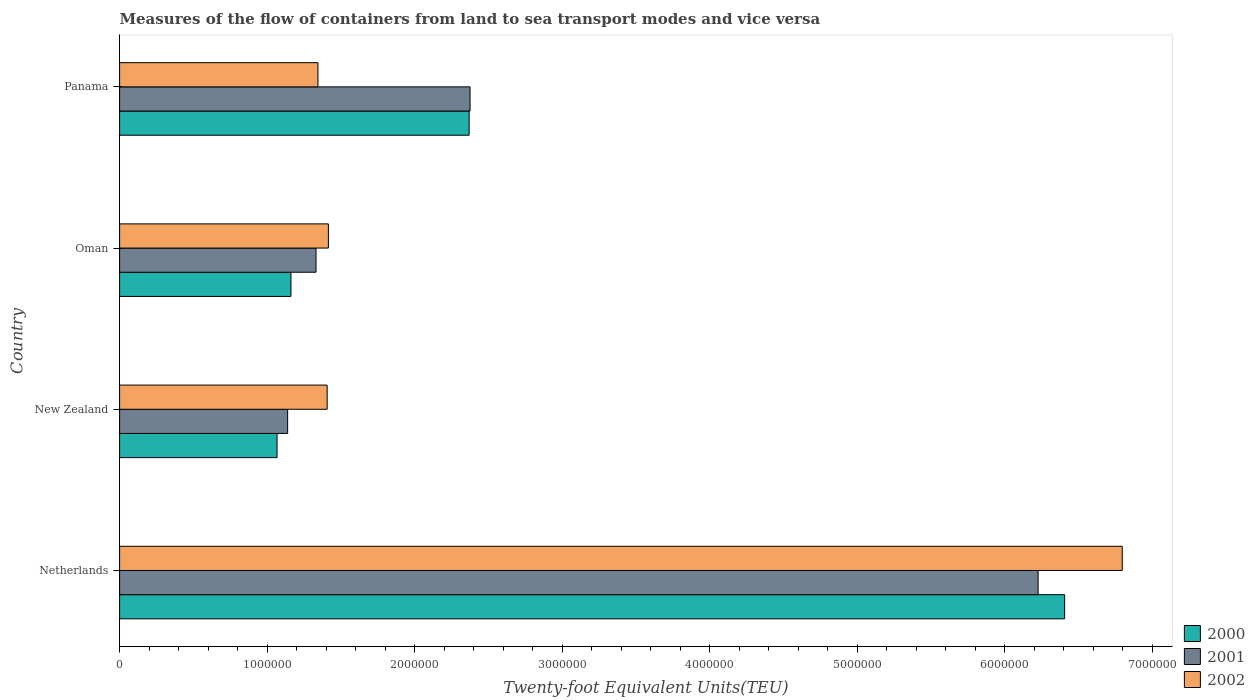Are the number of bars per tick equal to the number of legend labels?
Your answer should be very brief. Yes. How many bars are there on the 2nd tick from the bottom?
Your answer should be very brief. 3. What is the label of the 1st group of bars from the top?
Your answer should be very brief. Panama. In how many cases, is the number of bars for a given country not equal to the number of legend labels?
Your response must be concise. 0. What is the container port traffic in 2001 in Netherlands?
Your response must be concise. 6.23e+06. Across all countries, what is the maximum container port traffic in 2001?
Offer a very short reply. 6.23e+06. Across all countries, what is the minimum container port traffic in 2000?
Keep it short and to the point. 1.07e+06. In which country was the container port traffic in 2001 maximum?
Your answer should be very brief. Netherlands. In which country was the container port traffic in 2001 minimum?
Give a very brief answer. New Zealand. What is the total container port traffic in 2002 in the graph?
Your answer should be very brief. 1.10e+07. What is the difference between the container port traffic in 2000 in New Zealand and that in Oman?
Provide a short and direct response. -9.41e+04. What is the difference between the container port traffic in 2001 in Panama and the container port traffic in 2002 in Oman?
Provide a succinct answer. 9.61e+05. What is the average container port traffic in 2002 per country?
Your answer should be compact. 2.74e+06. What is the difference between the container port traffic in 2002 and container port traffic in 2001 in Oman?
Give a very brief answer. 8.38e+04. In how many countries, is the container port traffic in 2002 greater than 600000 TEU?
Give a very brief answer. 4. What is the ratio of the container port traffic in 2002 in Netherlands to that in Oman?
Keep it short and to the point. 4.8. What is the difference between the highest and the second highest container port traffic in 2002?
Offer a very short reply. 5.38e+06. What is the difference between the highest and the lowest container port traffic in 2002?
Ensure brevity in your answer.  5.45e+06. What does the 3rd bar from the top in Netherlands represents?
Provide a succinct answer. 2000. What is the difference between two consecutive major ticks on the X-axis?
Offer a terse response. 1.00e+06. Are the values on the major ticks of X-axis written in scientific E-notation?
Offer a very short reply. No. Does the graph contain any zero values?
Offer a very short reply. No. Does the graph contain grids?
Provide a succinct answer. No. What is the title of the graph?
Give a very brief answer. Measures of the flow of containers from land to sea transport modes and vice versa. What is the label or title of the X-axis?
Give a very brief answer. Twenty-foot Equivalent Units(TEU). What is the label or title of the Y-axis?
Provide a short and direct response. Country. What is the Twenty-foot Equivalent Units(TEU) in 2000 in Netherlands?
Keep it short and to the point. 6.41e+06. What is the Twenty-foot Equivalent Units(TEU) in 2001 in Netherlands?
Offer a very short reply. 6.23e+06. What is the Twenty-foot Equivalent Units(TEU) of 2002 in Netherlands?
Make the answer very short. 6.80e+06. What is the Twenty-foot Equivalent Units(TEU) of 2000 in New Zealand?
Ensure brevity in your answer.  1.07e+06. What is the Twenty-foot Equivalent Units(TEU) in 2001 in New Zealand?
Your answer should be very brief. 1.14e+06. What is the Twenty-foot Equivalent Units(TEU) of 2002 in New Zealand?
Ensure brevity in your answer.  1.41e+06. What is the Twenty-foot Equivalent Units(TEU) of 2000 in Oman?
Your response must be concise. 1.16e+06. What is the Twenty-foot Equivalent Units(TEU) of 2001 in Oman?
Give a very brief answer. 1.33e+06. What is the Twenty-foot Equivalent Units(TEU) in 2002 in Oman?
Your answer should be compact. 1.42e+06. What is the Twenty-foot Equivalent Units(TEU) of 2000 in Panama?
Provide a short and direct response. 2.37e+06. What is the Twenty-foot Equivalent Units(TEU) of 2001 in Panama?
Keep it short and to the point. 2.38e+06. What is the Twenty-foot Equivalent Units(TEU) in 2002 in Panama?
Offer a terse response. 1.34e+06. Across all countries, what is the maximum Twenty-foot Equivalent Units(TEU) in 2000?
Your answer should be compact. 6.41e+06. Across all countries, what is the maximum Twenty-foot Equivalent Units(TEU) in 2001?
Provide a short and direct response. 6.23e+06. Across all countries, what is the maximum Twenty-foot Equivalent Units(TEU) in 2002?
Your response must be concise. 6.80e+06. Across all countries, what is the minimum Twenty-foot Equivalent Units(TEU) in 2000?
Provide a succinct answer. 1.07e+06. Across all countries, what is the minimum Twenty-foot Equivalent Units(TEU) of 2001?
Offer a terse response. 1.14e+06. Across all countries, what is the minimum Twenty-foot Equivalent Units(TEU) of 2002?
Offer a very short reply. 1.34e+06. What is the total Twenty-foot Equivalent Units(TEU) of 2000 in the graph?
Provide a short and direct response. 1.10e+07. What is the total Twenty-foot Equivalent Units(TEU) in 2001 in the graph?
Provide a short and direct response. 1.11e+07. What is the total Twenty-foot Equivalent Units(TEU) in 2002 in the graph?
Give a very brief answer. 1.10e+07. What is the difference between the Twenty-foot Equivalent Units(TEU) in 2000 in Netherlands and that in New Zealand?
Your answer should be very brief. 5.34e+06. What is the difference between the Twenty-foot Equivalent Units(TEU) in 2001 in Netherlands and that in New Zealand?
Keep it short and to the point. 5.09e+06. What is the difference between the Twenty-foot Equivalent Units(TEU) in 2002 in Netherlands and that in New Zealand?
Provide a succinct answer. 5.39e+06. What is the difference between the Twenty-foot Equivalent Units(TEU) in 2000 in Netherlands and that in Oman?
Your response must be concise. 5.25e+06. What is the difference between the Twenty-foot Equivalent Units(TEU) of 2001 in Netherlands and that in Oman?
Provide a short and direct response. 4.90e+06. What is the difference between the Twenty-foot Equivalent Units(TEU) of 2002 in Netherlands and that in Oman?
Offer a terse response. 5.38e+06. What is the difference between the Twenty-foot Equivalent Units(TEU) of 2000 in Netherlands and that in Panama?
Keep it short and to the point. 4.04e+06. What is the difference between the Twenty-foot Equivalent Units(TEU) of 2001 in Netherlands and that in Panama?
Offer a terse response. 3.85e+06. What is the difference between the Twenty-foot Equivalent Units(TEU) in 2002 in Netherlands and that in Panama?
Your answer should be compact. 5.45e+06. What is the difference between the Twenty-foot Equivalent Units(TEU) of 2000 in New Zealand and that in Oman?
Provide a succinct answer. -9.41e+04. What is the difference between the Twenty-foot Equivalent Units(TEU) in 2001 in New Zealand and that in Oman?
Provide a succinct answer. -1.93e+05. What is the difference between the Twenty-foot Equivalent Units(TEU) in 2002 in New Zealand and that in Oman?
Give a very brief answer. -8370. What is the difference between the Twenty-foot Equivalent Units(TEU) of 2000 in New Zealand and that in Panama?
Provide a short and direct response. -1.30e+06. What is the difference between the Twenty-foot Equivalent Units(TEU) in 2001 in New Zealand and that in Panama?
Ensure brevity in your answer.  -1.24e+06. What is the difference between the Twenty-foot Equivalent Units(TEU) in 2002 in New Zealand and that in Panama?
Offer a terse response. 6.23e+04. What is the difference between the Twenty-foot Equivalent Units(TEU) of 2000 in Oman and that in Panama?
Provide a short and direct response. -1.21e+06. What is the difference between the Twenty-foot Equivalent Units(TEU) in 2001 in Oman and that in Panama?
Give a very brief answer. -1.04e+06. What is the difference between the Twenty-foot Equivalent Units(TEU) in 2002 in Oman and that in Panama?
Your response must be concise. 7.07e+04. What is the difference between the Twenty-foot Equivalent Units(TEU) of 2000 in Netherlands and the Twenty-foot Equivalent Units(TEU) of 2001 in New Zealand?
Keep it short and to the point. 5.27e+06. What is the difference between the Twenty-foot Equivalent Units(TEU) in 2000 in Netherlands and the Twenty-foot Equivalent Units(TEU) in 2002 in New Zealand?
Your answer should be compact. 5.00e+06. What is the difference between the Twenty-foot Equivalent Units(TEU) of 2001 in Netherlands and the Twenty-foot Equivalent Units(TEU) of 2002 in New Zealand?
Give a very brief answer. 4.82e+06. What is the difference between the Twenty-foot Equivalent Units(TEU) in 2000 in Netherlands and the Twenty-foot Equivalent Units(TEU) in 2001 in Oman?
Make the answer very short. 5.08e+06. What is the difference between the Twenty-foot Equivalent Units(TEU) in 2000 in Netherlands and the Twenty-foot Equivalent Units(TEU) in 2002 in Oman?
Keep it short and to the point. 4.99e+06. What is the difference between the Twenty-foot Equivalent Units(TEU) of 2001 in Netherlands and the Twenty-foot Equivalent Units(TEU) of 2002 in Oman?
Make the answer very short. 4.81e+06. What is the difference between the Twenty-foot Equivalent Units(TEU) in 2000 in Netherlands and the Twenty-foot Equivalent Units(TEU) in 2001 in Panama?
Provide a short and direct response. 4.03e+06. What is the difference between the Twenty-foot Equivalent Units(TEU) of 2000 in Netherlands and the Twenty-foot Equivalent Units(TEU) of 2002 in Panama?
Your answer should be compact. 5.06e+06. What is the difference between the Twenty-foot Equivalent Units(TEU) in 2001 in Netherlands and the Twenty-foot Equivalent Units(TEU) in 2002 in Panama?
Offer a terse response. 4.88e+06. What is the difference between the Twenty-foot Equivalent Units(TEU) of 2000 in New Zealand and the Twenty-foot Equivalent Units(TEU) of 2001 in Oman?
Make the answer very short. -2.64e+05. What is the difference between the Twenty-foot Equivalent Units(TEU) of 2000 in New Zealand and the Twenty-foot Equivalent Units(TEU) of 2002 in Oman?
Give a very brief answer. -3.48e+05. What is the difference between the Twenty-foot Equivalent Units(TEU) in 2001 in New Zealand and the Twenty-foot Equivalent Units(TEU) in 2002 in Oman?
Offer a terse response. -2.76e+05. What is the difference between the Twenty-foot Equivalent Units(TEU) of 2000 in New Zealand and the Twenty-foot Equivalent Units(TEU) of 2001 in Panama?
Provide a succinct answer. -1.31e+06. What is the difference between the Twenty-foot Equivalent Units(TEU) in 2000 in New Zealand and the Twenty-foot Equivalent Units(TEU) in 2002 in Panama?
Provide a succinct answer. -2.77e+05. What is the difference between the Twenty-foot Equivalent Units(TEU) of 2001 in New Zealand and the Twenty-foot Equivalent Units(TEU) of 2002 in Panama?
Ensure brevity in your answer.  -2.06e+05. What is the difference between the Twenty-foot Equivalent Units(TEU) in 2000 in Oman and the Twenty-foot Equivalent Units(TEU) in 2001 in Panama?
Your answer should be compact. -1.21e+06. What is the difference between the Twenty-foot Equivalent Units(TEU) in 2000 in Oman and the Twenty-foot Equivalent Units(TEU) in 2002 in Panama?
Make the answer very short. -1.83e+05. What is the difference between the Twenty-foot Equivalent Units(TEU) of 2001 in Oman and the Twenty-foot Equivalent Units(TEU) of 2002 in Panama?
Your answer should be very brief. -1.31e+04. What is the average Twenty-foot Equivalent Units(TEU) in 2000 per country?
Offer a terse response. 2.75e+06. What is the average Twenty-foot Equivalent Units(TEU) of 2001 per country?
Provide a succinct answer. 2.77e+06. What is the average Twenty-foot Equivalent Units(TEU) of 2002 per country?
Make the answer very short. 2.74e+06. What is the difference between the Twenty-foot Equivalent Units(TEU) in 2000 and Twenty-foot Equivalent Units(TEU) in 2001 in Netherlands?
Offer a terse response. 1.80e+05. What is the difference between the Twenty-foot Equivalent Units(TEU) in 2000 and Twenty-foot Equivalent Units(TEU) in 2002 in Netherlands?
Provide a succinct answer. -3.90e+05. What is the difference between the Twenty-foot Equivalent Units(TEU) in 2001 and Twenty-foot Equivalent Units(TEU) in 2002 in Netherlands?
Make the answer very short. -5.70e+05. What is the difference between the Twenty-foot Equivalent Units(TEU) of 2000 and Twenty-foot Equivalent Units(TEU) of 2001 in New Zealand?
Offer a terse response. -7.17e+04. What is the difference between the Twenty-foot Equivalent Units(TEU) of 2000 and Twenty-foot Equivalent Units(TEU) of 2002 in New Zealand?
Your answer should be compact. -3.40e+05. What is the difference between the Twenty-foot Equivalent Units(TEU) in 2001 and Twenty-foot Equivalent Units(TEU) in 2002 in New Zealand?
Offer a terse response. -2.68e+05. What is the difference between the Twenty-foot Equivalent Units(TEU) in 2000 and Twenty-foot Equivalent Units(TEU) in 2001 in Oman?
Offer a very short reply. -1.70e+05. What is the difference between the Twenty-foot Equivalent Units(TEU) of 2000 and Twenty-foot Equivalent Units(TEU) of 2002 in Oman?
Your response must be concise. -2.54e+05. What is the difference between the Twenty-foot Equivalent Units(TEU) of 2001 and Twenty-foot Equivalent Units(TEU) of 2002 in Oman?
Your answer should be very brief. -8.38e+04. What is the difference between the Twenty-foot Equivalent Units(TEU) of 2000 and Twenty-foot Equivalent Units(TEU) of 2001 in Panama?
Your response must be concise. -6364. What is the difference between the Twenty-foot Equivalent Units(TEU) in 2000 and Twenty-foot Equivalent Units(TEU) in 2002 in Panama?
Provide a succinct answer. 1.02e+06. What is the difference between the Twenty-foot Equivalent Units(TEU) in 2001 and Twenty-foot Equivalent Units(TEU) in 2002 in Panama?
Provide a short and direct response. 1.03e+06. What is the ratio of the Twenty-foot Equivalent Units(TEU) in 2000 in Netherlands to that in New Zealand?
Provide a short and direct response. 6. What is the ratio of the Twenty-foot Equivalent Units(TEU) in 2001 in Netherlands to that in New Zealand?
Your answer should be very brief. 5.47. What is the ratio of the Twenty-foot Equivalent Units(TEU) in 2002 in Netherlands to that in New Zealand?
Offer a terse response. 4.83. What is the ratio of the Twenty-foot Equivalent Units(TEU) in 2000 in Netherlands to that in Oman?
Make the answer very short. 5.52. What is the ratio of the Twenty-foot Equivalent Units(TEU) of 2001 in Netherlands to that in Oman?
Your answer should be compact. 4.68. What is the ratio of the Twenty-foot Equivalent Units(TEU) in 2002 in Netherlands to that in Oman?
Ensure brevity in your answer.  4.8. What is the ratio of the Twenty-foot Equivalent Units(TEU) of 2000 in Netherlands to that in Panama?
Keep it short and to the point. 2.7. What is the ratio of the Twenty-foot Equivalent Units(TEU) of 2001 in Netherlands to that in Panama?
Keep it short and to the point. 2.62. What is the ratio of the Twenty-foot Equivalent Units(TEU) in 2002 in Netherlands to that in Panama?
Provide a short and direct response. 5.05. What is the ratio of the Twenty-foot Equivalent Units(TEU) in 2000 in New Zealand to that in Oman?
Keep it short and to the point. 0.92. What is the ratio of the Twenty-foot Equivalent Units(TEU) in 2001 in New Zealand to that in Oman?
Give a very brief answer. 0.86. What is the ratio of the Twenty-foot Equivalent Units(TEU) in 2002 in New Zealand to that in Oman?
Your answer should be very brief. 0.99. What is the ratio of the Twenty-foot Equivalent Units(TEU) of 2000 in New Zealand to that in Panama?
Give a very brief answer. 0.45. What is the ratio of the Twenty-foot Equivalent Units(TEU) of 2001 in New Zealand to that in Panama?
Your answer should be compact. 0.48. What is the ratio of the Twenty-foot Equivalent Units(TEU) in 2002 in New Zealand to that in Panama?
Ensure brevity in your answer.  1.05. What is the ratio of the Twenty-foot Equivalent Units(TEU) in 2000 in Oman to that in Panama?
Keep it short and to the point. 0.49. What is the ratio of the Twenty-foot Equivalent Units(TEU) in 2001 in Oman to that in Panama?
Give a very brief answer. 0.56. What is the ratio of the Twenty-foot Equivalent Units(TEU) in 2002 in Oman to that in Panama?
Offer a very short reply. 1.05. What is the difference between the highest and the second highest Twenty-foot Equivalent Units(TEU) of 2000?
Your answer should be compact. 4.04e+06. What is the difference between the highest and the second highest Twenty-foot Equivalent Units(TEU) in 2001?
Keep it short and to the point. 3.85e+06. What is the difference between the highest and the second highest Twenty-foot Equivalent Units(TEU) of 2002?
Keep it short and to the point. 5.38e+06. What is the difference between the highest and the lowest Twenty-foot Equivalent Units(TEU) of 2000?
Provide a succinct answer. 5.34e+06. What is the difference between the highest and the lowest Twenty-foot Equivalent Units(TEU) of 2001?
Offer a terse response. 5.09e+06. What is the difference between the highest and the lowest Twenty-foot Equivalent Units(TEU) of 2002?
Keep it short and to the point. 5.45e+06. 